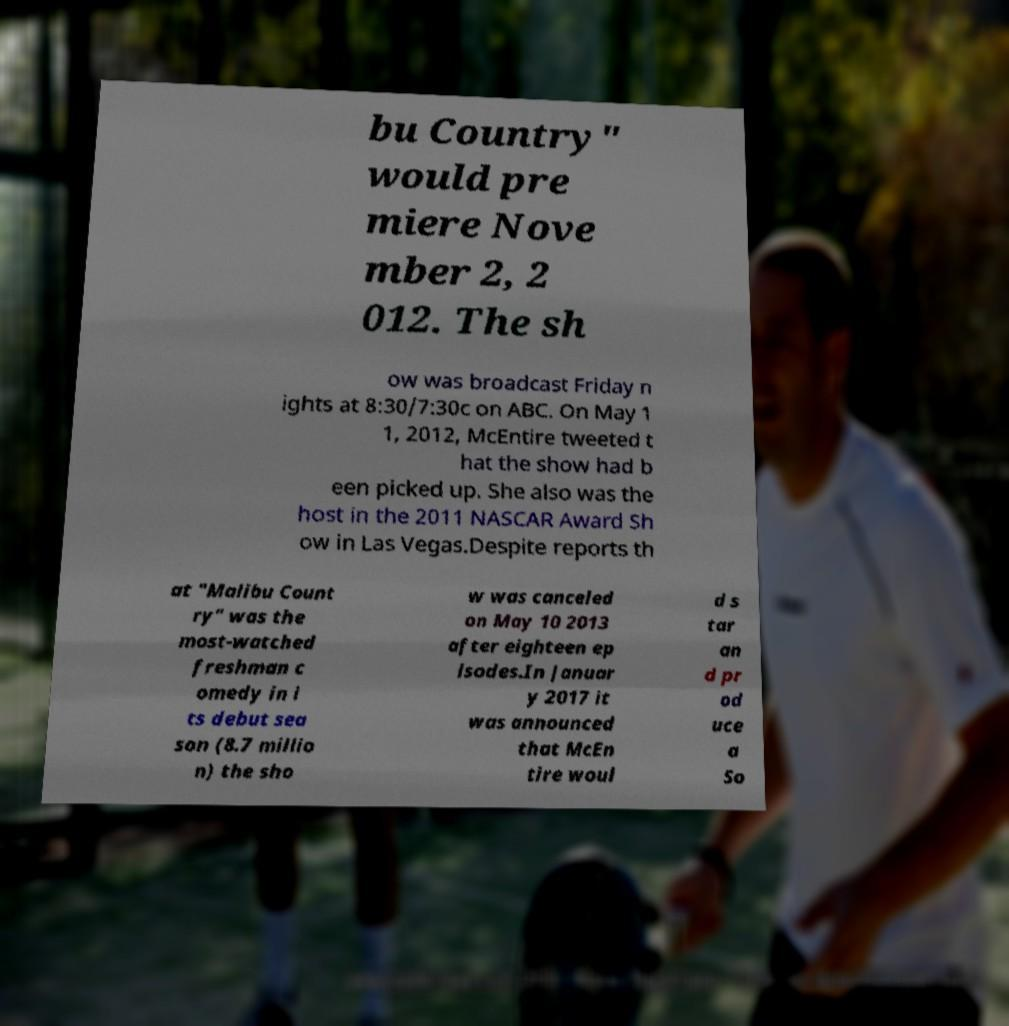I need the written content from this picture converted into text. Can you do that? bu Country" would pre miere Nove mber 2, 2 012. The sh ow was broadcast Friday n ights at 8:30/7:30c on ABC. On May 1 1, 2012, McEntire tweeted t hat the show had b een picked up. She also was the host in the 2011 NASCAR Award Sh ow in Las Vegas.Despite reports th at "Malibu Count ry" was the most-watched freshman c omedy in i ts debut sea son (8.7 millio n) the sho w was canceled on May 10 2013 after eighteen ep isodes.In Januar y 2017 it was announced that McEn tire woul d s tar an d pr od uce a So 